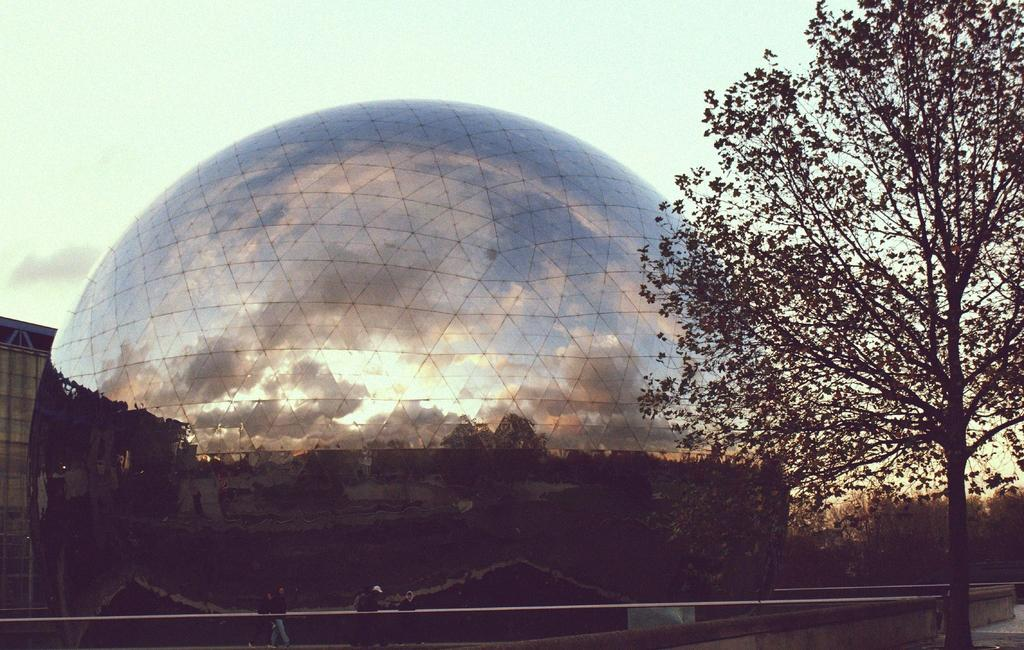What type of construction is depicted in the image? There is a domed shaped construction in the image. What feature can be seen on the construction? The construction has a mirror reflection on it. What is located on the right side of the image? There is a tree on the right side of the image. What can be seen in the background of the image? There are many trees in the background of the image. What is visible above the construction? The sky is visible above the construction. What type of ring is hanging from the tree in the image? There is no ring hanging from the tree in the image; only a tree is present on the right side. What ornament is placed on top of the construction in the image? There is no ornament mentioned in the image; the focus is on the domed shaped construction and its mirror reflection. 